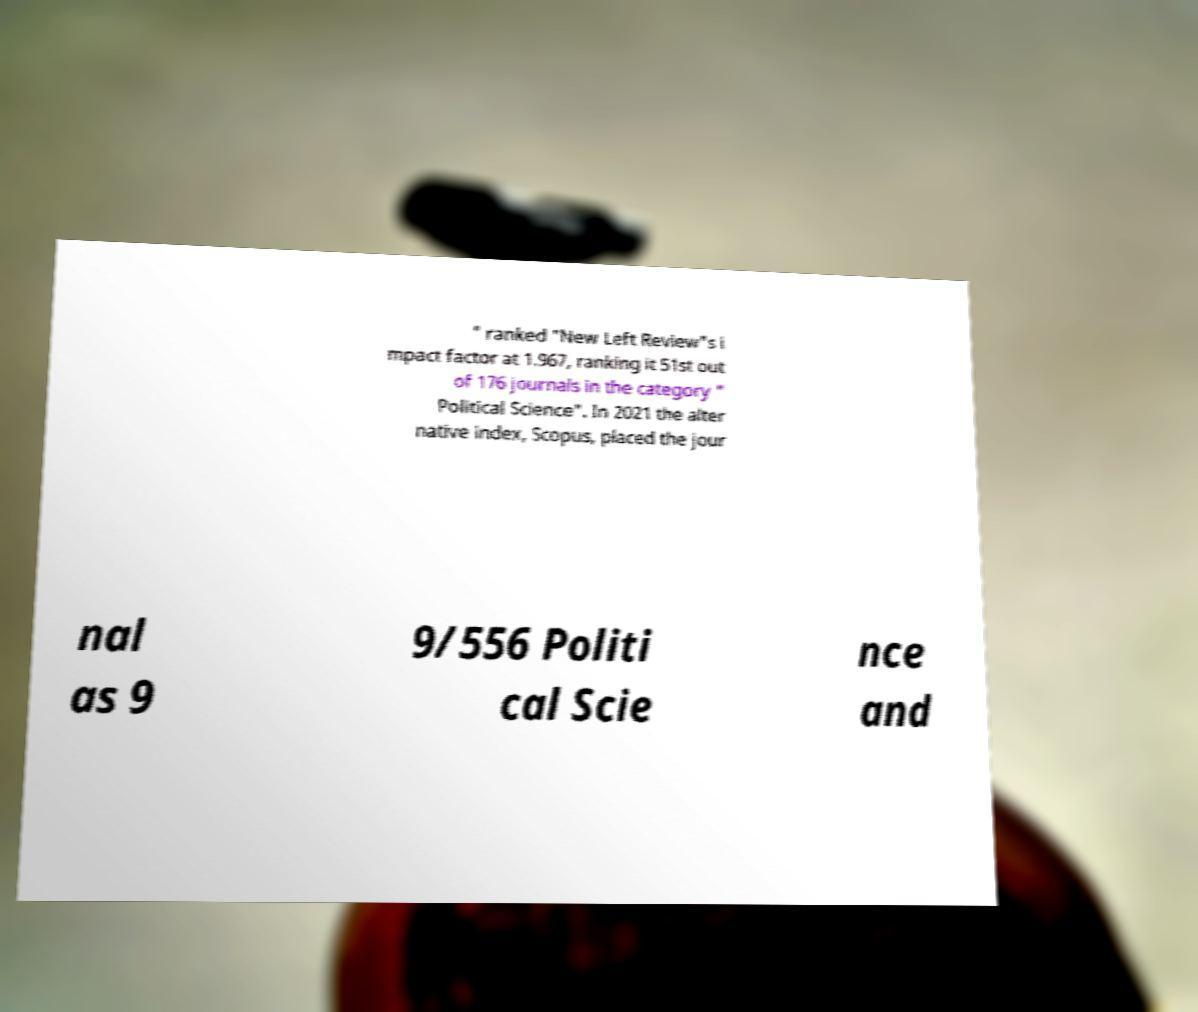I need the written content from this picture converted into text. Can you do that? " ranked "New Left Review"s i mpact factor at 1.967, ranking it 51st out of 176 journals in the category " Political Science". In 2021 the alter native index, Scopus, placed the jour nal as 9 9/556 Politi cal Scie nce and 